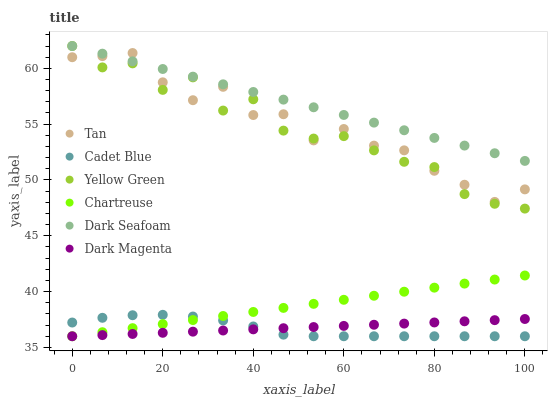Does Cadet Blue have the minimum area under the curve?
Answer yes or no. Yes. Does Dark Seafoam have the maximum area under the curve?
Answer yes or no. Yes. Does Yellow Green have the minimum area under the curve?
Answer yes or no. No. Does Yellow Green have the maximum area under the curve?
Answer yes or no. No. Is Dark Magenta the smoothest?
Answer yes or no. Yes. Is Yellow Green the roughest?
Answer yes or no. Yes. Is Chartreuse the smoothest?
Answer yes or no. No. Is Chartreuse the roughest?
Answer yes or no. No. Does Cadet Blue have the lowest value?
Answer yes or no. Yes. Does Yellow Green have the lowest value?
Answer yes or no. No. Does Dark Seafoam have the highest value?
Answer yes or no. Yes. Does Chartreuse have the highest value?
Answer yes or no. No. Is Chartreuse less than Yellow Green?
Answer yes or no. Yes. Is Yellow Green greater than Chartreuse?
Answer yes or no. Yes. Does Cadet Blue intersect Dark Magenta?
Answer yes or no. Yes. Is Cadet Blue less than Dark Magenta?
Answer yes or no. No. Is Cadet Blue greater than Dark Magenta?
Answer yes or no. No. Does Chartreuse intersect Yellow Green?
Answer yes or no. No. 